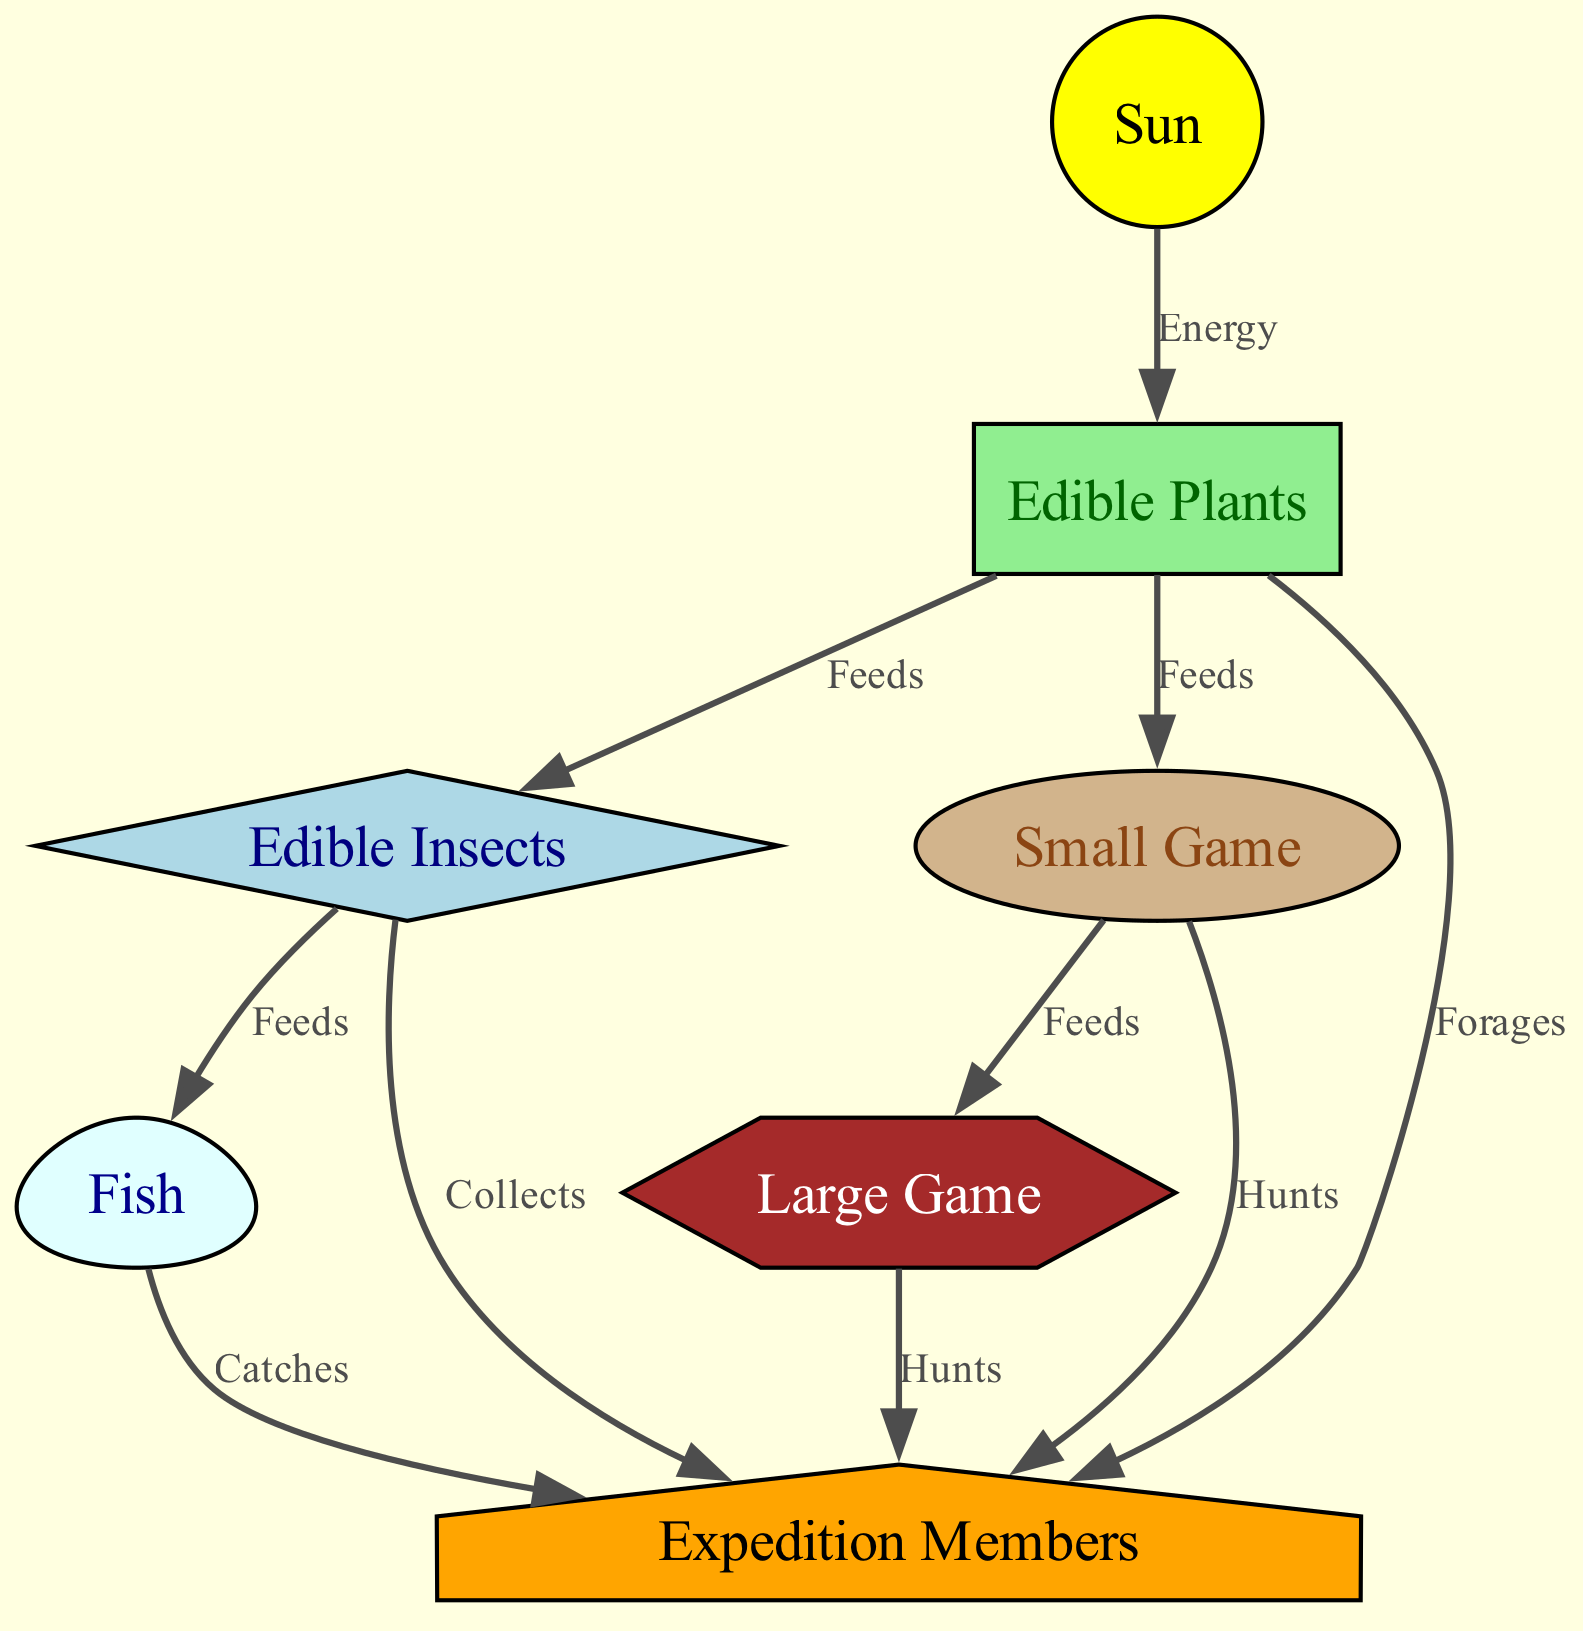What is the primary energy source in the food chain? The diagram indicates that the energy source is the "Sun," which feeds energy to plants, the foundational element of the food chain.
Answer: Sun How many major types of animals are included in the food chain? In the diagram, there are three major types of animals mentioned: "Small Game," "Large Game," and "Fish." Thus, the total is three.
Answer: 3 Which element is directly fed by both plants and insects? Reviewing the diagram shows that "Fish" is directly fed by insects, while plants feed small animals. Hence, "Fish" is the only one directly fed by "Insects."
Answer: Fish What do expedition members forage for? The diagram clearly states that expedition members forage for "Plants," indicating that edible plants are a source of food for them.
Answer: Plants Which two elements are connected by the label "Feeds"? The diagram illustrates a connection labeled "Feeds" between "Plants" and "Insects," emphasizing that insects are nourished by plants.
Answer: Plants and Insects How many relationships do plants have in the food chain? Analyzing the diagram, plants have four relationships: they provide energy to insects, feed small animals, and forage for humans, accounting for three connections. Thus, the total is three.
Answer: 3 Which type of food do expedition members hunt for? The diagram indicates that expedition members can hunt for both "Small Game" and "Large Game," showing their hunting opportunities in the chain.
Answer: Small Game and Large Game What feeds on small animals in the food chain? The diagram shows that "Large Animals" are fed by "Small Game," indicating that small animals serve as a food source for large animals.
Answer: Large Animals What role do insects play in relation to plants? According to the diagram, insects are specifically labeled as being "Fed" by plants, signifying their role as a consumer in the food chain.
Answer: Fed by Plants 